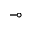Convert formula to latex. <formula><loc_0><loc_0><loc_500><loc_500>\mu l t i m a p</formula> 